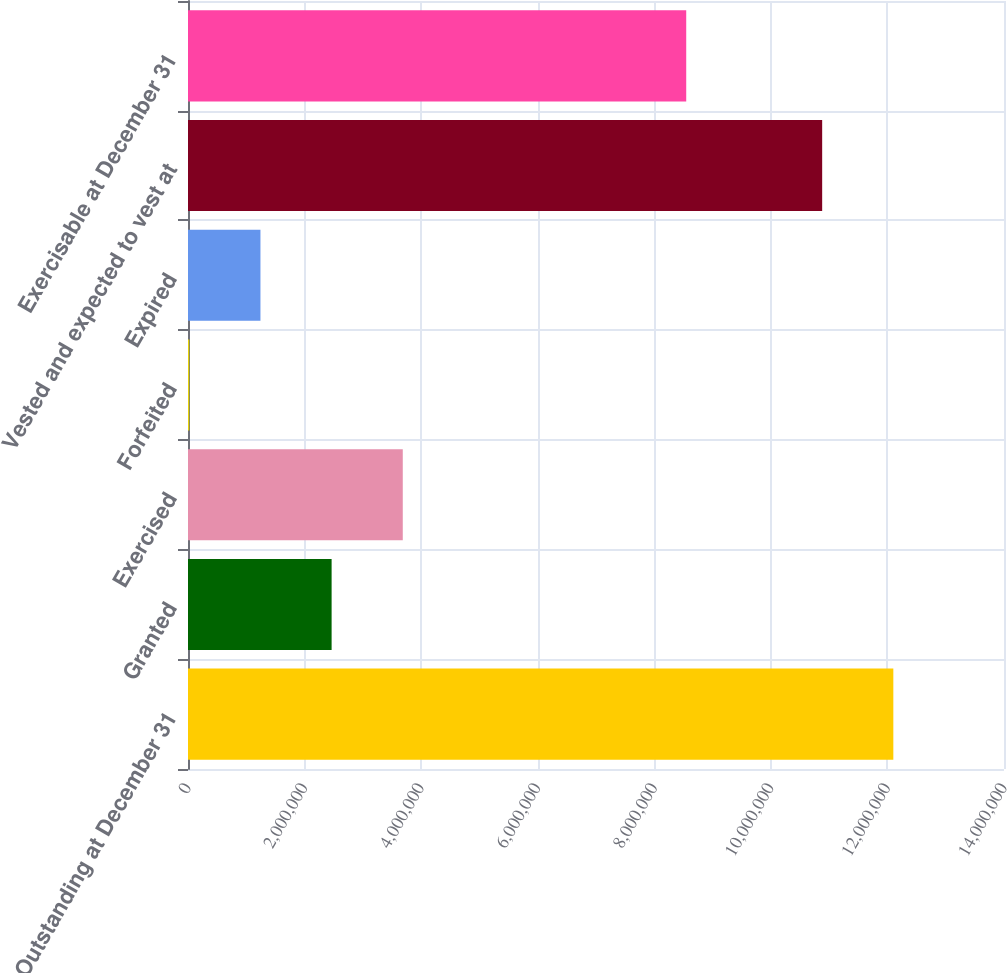Convert chart. <chart><loc_0><loc_0><loc_500><loc_500><bar_chart><fcel>Outstanding at December 31<fcel>Granted<fcel>Exercised<fcel>Forfeited<fcel>Expired<fcel>Vested and expected to vest at<fcel>Exercisable at December 31<nl><fcel>1.21013e+07<fcel>2.46396e+06<fcel>3.6849e+06<fcel>22074<fcel>1.24302e+06<fcel>1.08803e+07<fcel>8.54793e+06<nl></chart> 